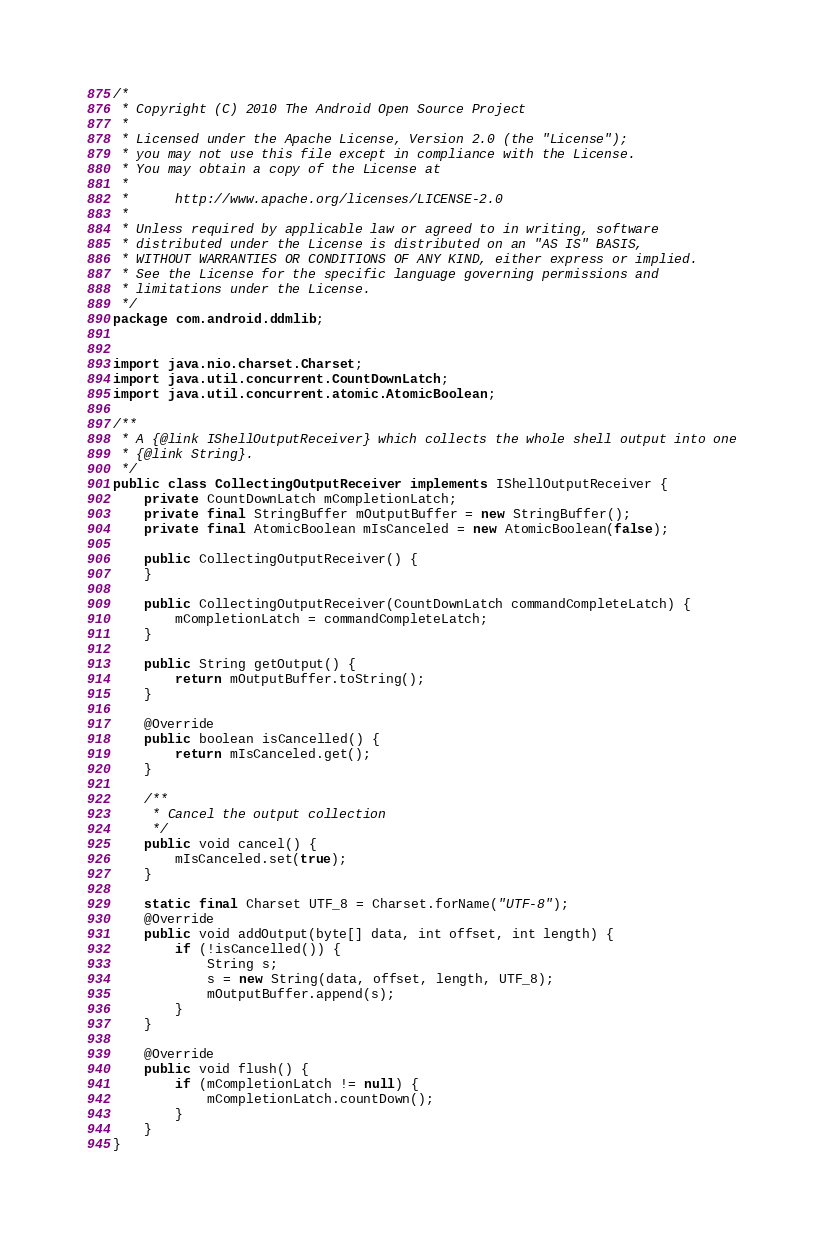Convert code to text. <code><loc_0><loc_0><loc_500><loc_500><_Java_>/*
 * Copyright (C) 2010 The Android Open Source Project
 *
 * Licensed under the Apache License, Version 2.0 (the "License");
 * you may not use this file except in compliance with the License.
 * You may obtain a copy of the License at
 *
 *      http://www.apache.org/licenses/LICENSE-2.0
 *
 * Unless required by applicable law or agreed to in writing, software
 * distributed under the License is distributed on an "AS IS" BASIS,
 * WITHOUT WARRANTIES OR CONDITIONS OF ANY KIND, either express or implied.
 * See the License for the specific language governing permissions and
 * limitations under the License.
 */
package com.android.ddmlib;


import java.nio.charset.Charset;
import java.util.concurrent.CountDownLatch;
import java.util.concurrent.atomic.AtomicBoolean;

/**
 * A {@link IShellOutputReceiver} which collects the whole shell output into one
 * {@link String}.
 */
public class CollectingOutputReceiver implements IShellOutputReceiver {
    private CountDownLatch mCompletionLatch;
    private final StringBuffer mOutputBuffer = new StringBuffer();
    private final AtomicBoolean mIsCanceled = new AtomicBoolean(false);

    public CollectingOutputReceiver() {
    }

    public CollectingOutputReceiver(CountDownLatch commandCompleteLatch) {
        mCompletionLatch = commandCompleteLatch;
    }

    public String getOutput() {
        return mOutputBuffer.toString();
    }

    @Override
    public boolean isCancelled() {
        return mIsCanceled.get();
    }

    /**
     * Cancel the output collection
     */
    public void cancel() {
        mIsCanceled.set(true);
    }

    static final Charset UTF_8 = Charset.forName("UTF-8");
    @Override
    public void addOutput(byte[] data, int offset, int length) {
        if (!isCancelled()) {
            String s;
            s = new String(data, offset, length, UTF_8);
            mOutputBuffer.append(s);
        }
    }

    @Override
    public void flush() {
        if (mCompletionLatch != null) {
            mCompletionLatch.countDown();
        }
    }
}
</code> 